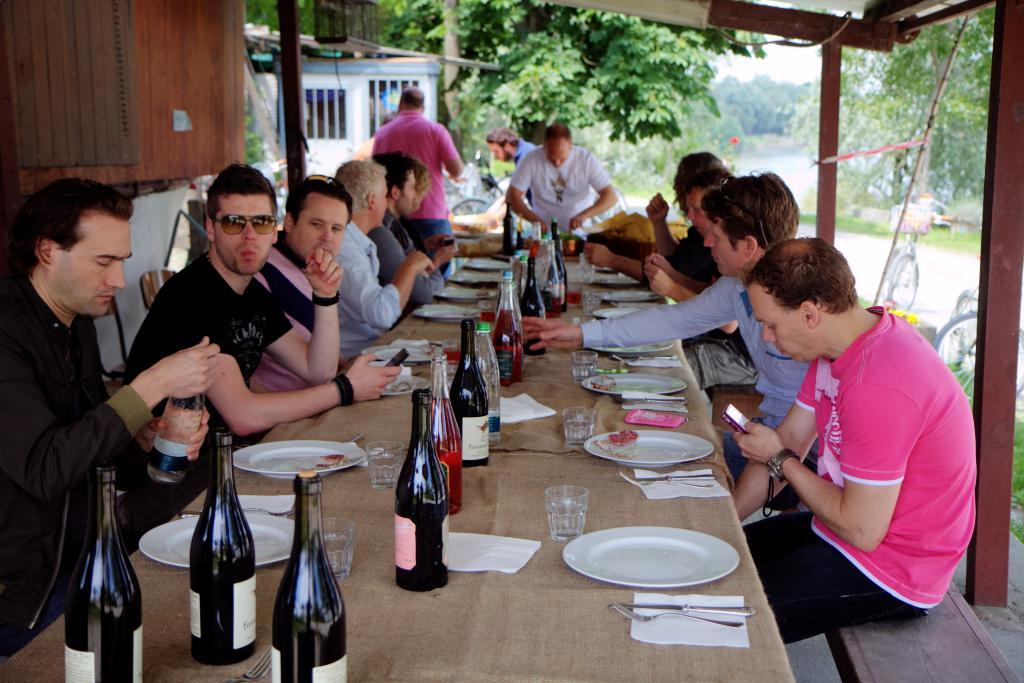How many people are in the image? There is a group of people in the image. What are the people doing in the image? The people are sitting on a chair and having food and wine. What can be seen in the background of the image? There is a tree, a bicycle, and a hut in the background of the image. What type of cherry is being used to flavor the wine in the image? There is no mention of cherries or flavors in the image; it only shows people having food and wine. Can you hear the people's voices in the image? The image is a still picture, so we cannot hear any voices or sounds. 